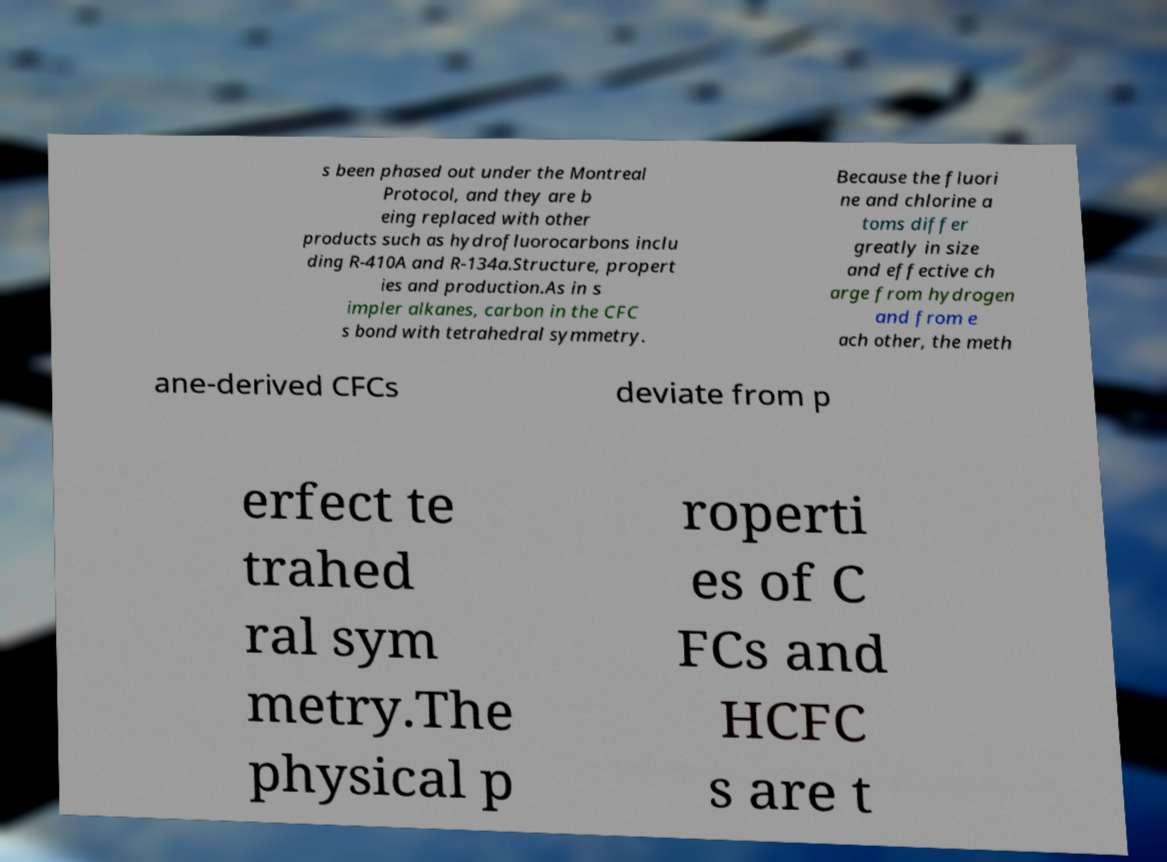There's text embedded in this image that I need extracted. Can you transcribe it verbatim? s been phased out under the Montreal Protocol, and they are b eing replaced with other products such as hydrofluorocarbons inclu ding R-410A and R-134a.Structure, propert ies and production.As in s impler alkanes, carbon in the CFC s bond with tetrahedral symmetry. Because the fluori ne and chlorine a toms differ greatly in size and effective ch arge from hydrogen and from e ach other, the meth ane-derived CFCs deviate from p erfect te trahed ral sym metry.The physical p roperti es of C FCs and HCFC s are t 